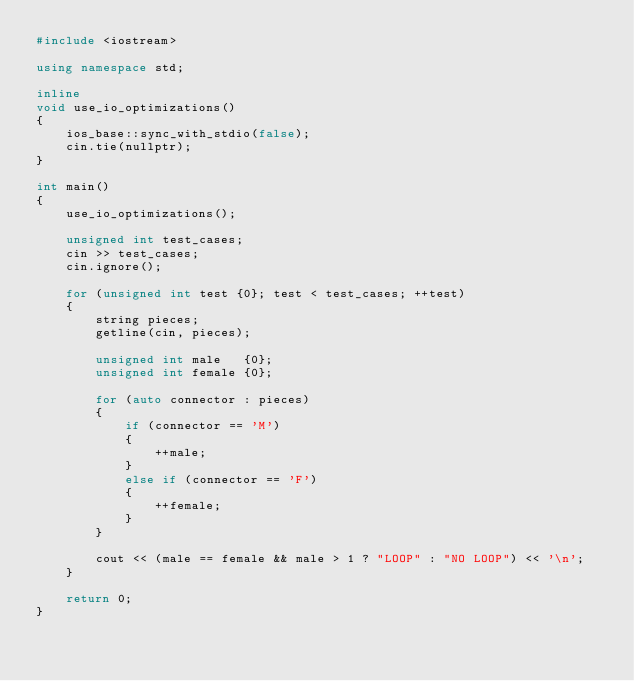<code> <loc_0><loc_0><loc_500><loc_500><_C++_>#include <iostream>

using namespace std;

inline
void use_io_optimizations()
{
    ios_base::sync_with_stdio(false);
    cin.tie(nullptr);
}

int main()
{
    use_io_optimizations();

    unsigned int test_cases;
    cin >> test_cases;
    cin.ignore();

    for (unsigned int test {0}; test < test_cases; ++test)
    {
        string pieces;
        getline(cin, pieces);

        unsigned int male   {0};
        unsigned int female {0};

        for (auto connector : pieces)
        {
            if (connector == 'M')
            {
                ++male;
            }
            else if (connector == 'F')
            {
                ++female;
            }
        }

        cout << (male == female && male > 1 ? "LOOP" : "NO LOOP") << '\n';
    }

    return 0;
}
</code> 